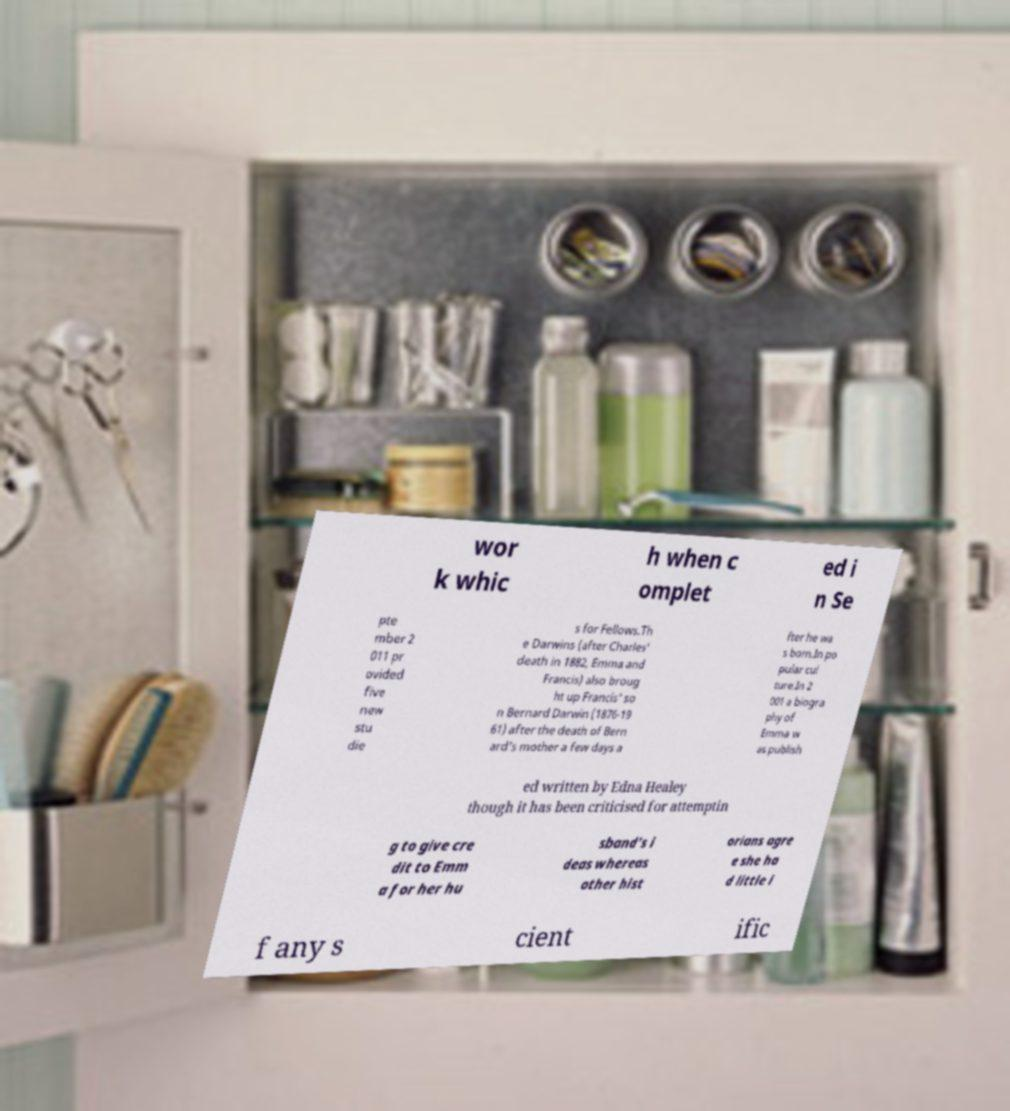Please read and relay the text visible in this image. What does it say? wor k whic h when c omplet ed i n Se pte mber 2 011 pr ovided five new stu die s for Fellows.Th e Darwins (after Charles' death in 1882, Emma and Francis) also broug ht up Francis' so n Bernard Darwin (1876-19 61) after the death of Bern ard's mother a few days a fter he wa s born.In po pular cul ture.In 2 001 a biogra phy of Emma w as publish ed written by Edna Healey though it has been criticised for attemptin g to give cre dit to Emm a for her hu sband's i deas whereas other hist orians agre e she ha d little i f any s cient ific 